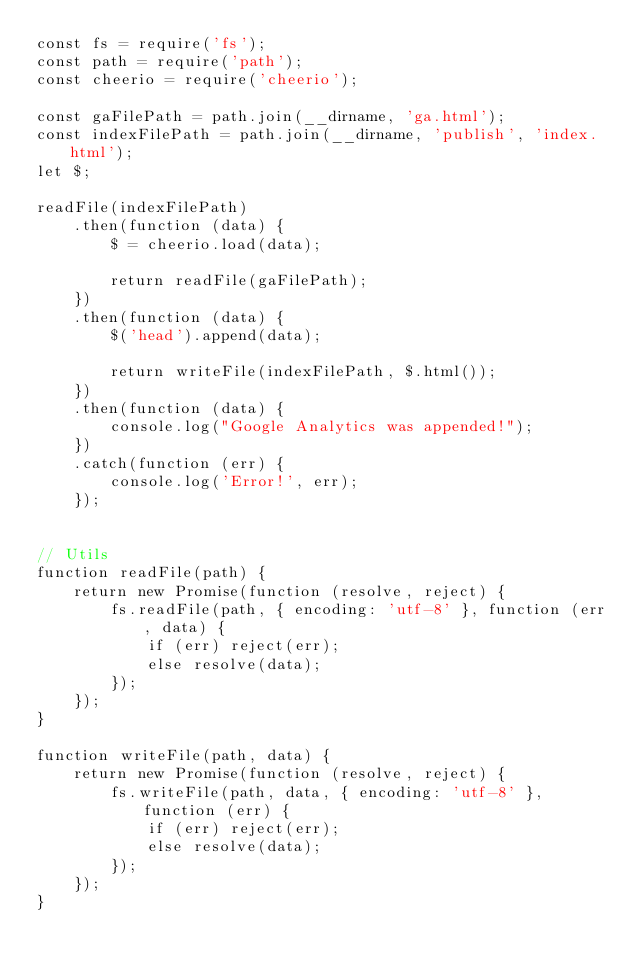Convert code to text. <code><loc_0><loc_0><loc_500><loc_500><_JavaScript_>const fs = require('fs');
const path = require('path');
const cheerio = require('cheerio');

const gaFilePath = path.join(__dirname, 'ga.html');
const indexFilePath = path.join(__dirname, 'publish', 'index.html');
let $;

readFile(indexFilePath)
    .then(function (data) {
        $ = cheerio.load(data);

        return readFile(gaFilePath);
    })
    .then(function (data) {
        $('head').append(data);

        return writeFile(indexFilePath, $.html());
    })
    .then(function (data) {
        console.log("Google Analytics was appended!");
    })
    .catch(function (err) {
        console.log('Error!', err);
    });


// Utils
function readFile(path) {
    return new Promise(function (resolve, reject) {
        fs.readFile(path, { encoding: 'utf-8' }, function (err, data) {
            if (err) reject(err);
            else resolve(data);
        });
    });
}

function writeFile(path, data) {
    return new Promise(function (resolve, reject) {
        fs.writeFile(path, data, { encoding: 'utf-8' }, function (err) {
            if (err) reject(err);
            else resolve(data);
        });
    });
}</code> 